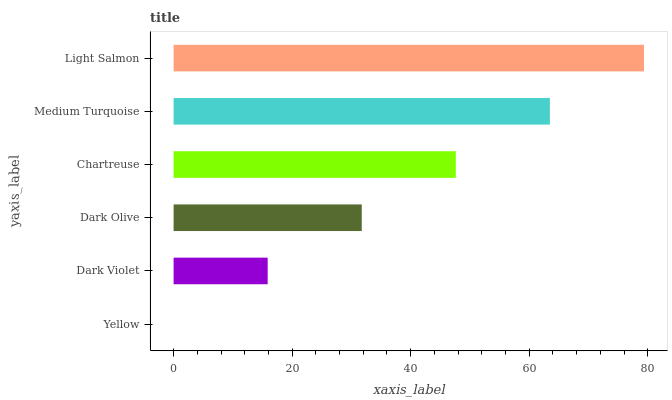Is Yellow the minimum?
Answer yes or no. Yes. Is Light Salmon the maximum?
Answer yes or no. Yes. Is Dark Violet the minimum?
Answer yes or no. No. Is Dark Violet the maximum?
Answer yes or no. No. Is Dark Violet greater than Yellow?
Answer yes or no. Yes. Is Yellow less than Dark Violet?
Answer yes or no. Yes. Is Yellow greater than Dark Violet?
Answer yes or no. No. Is Dark Violet less than Yellow?
Answer yes or no. No. Is Chartreuse the high median?
Answer yes or no. Yes. Is Dark Olive the low median?
Answer yes or no. Yes. Is Dark Violet the high median?
Answer yes or no. No. Is Yellow the low median?
Answer yes or no. No. 